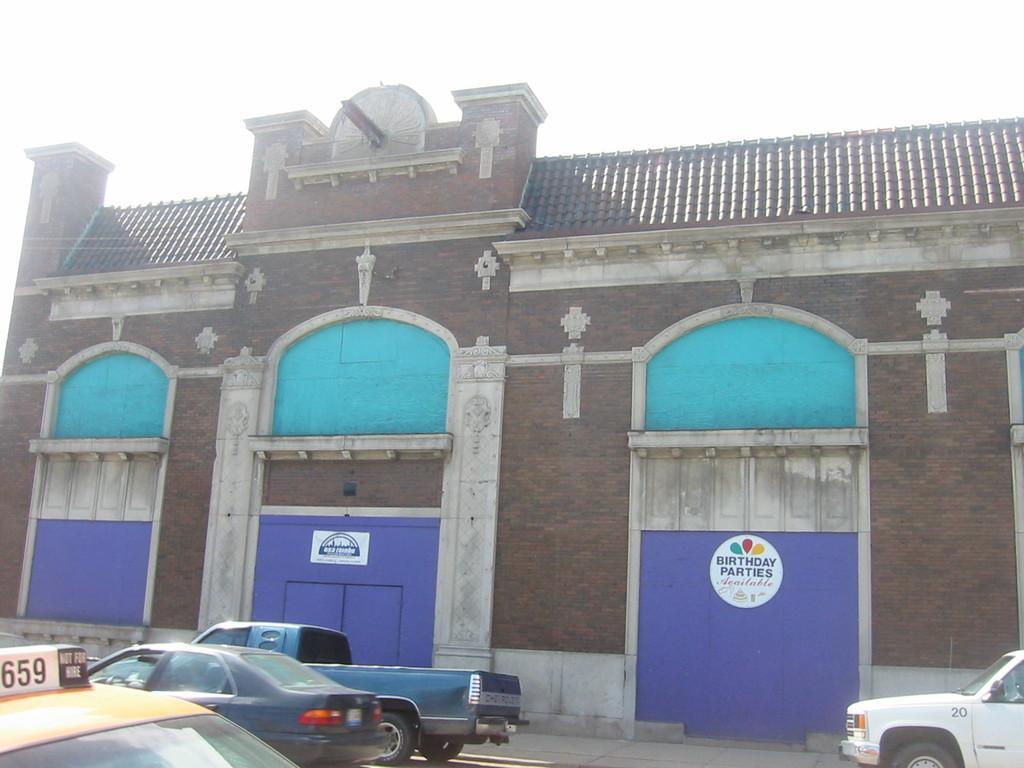In one or two sentences, can you explain what this image depicts? In this picture we can see a building, there are four vehicles at the bottom, we can see two boards pasted on the wall, there is some text on these boards, we can see the sky at the top of the picture. 